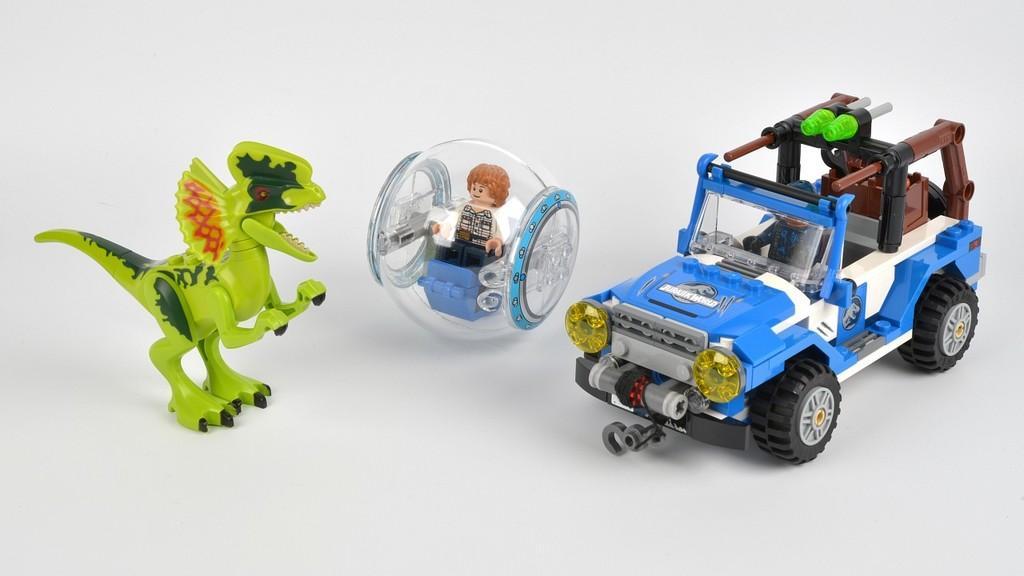In one or two sentences, can you explain what this image depicts? In this image I can see some toys on the white surface. 